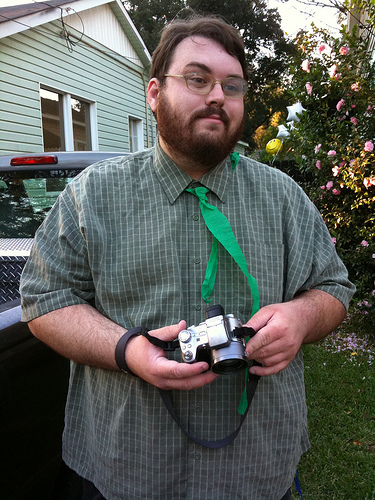What are the roses on? The roses are blooming on a well-maintained rose bush, which is evident by the multiple blooms and green leaves. 